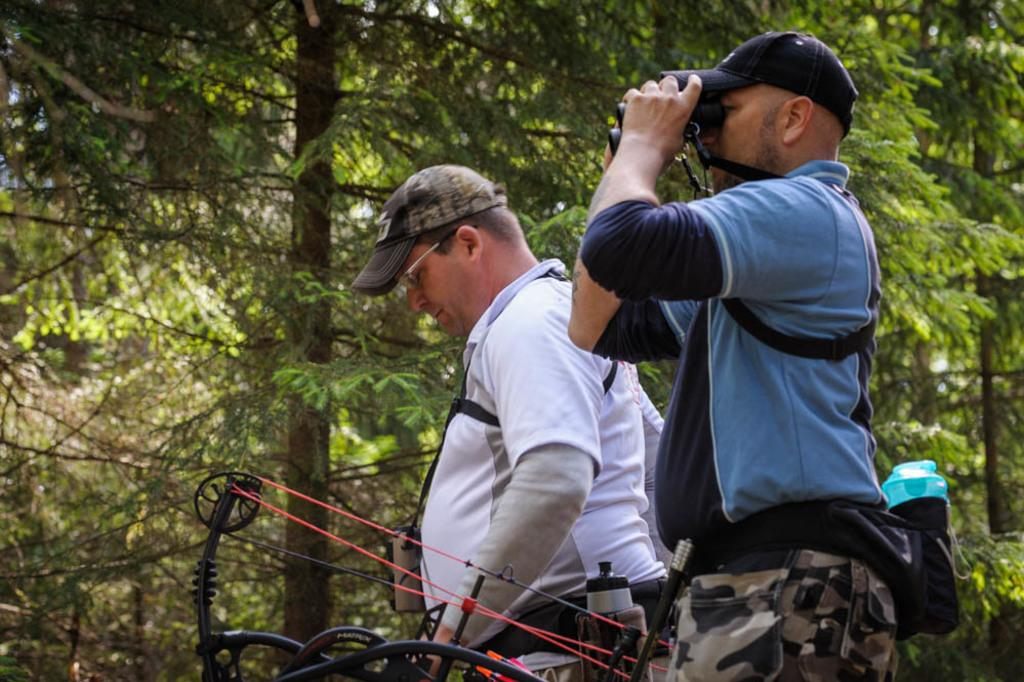How many people are present in the image? There are two people standing in the image. What is one person holding in the image? One person is holding binoculars. What is the object in front of the people? The facts do not specify the object in front of the people, so we cannot answer this question definitively. What can be seen in the background of the image? There are trees visible behind the people. What type of stick can be seen in the hands of the person on the left? There is no stick present in the image; one person is holding binoculars. 